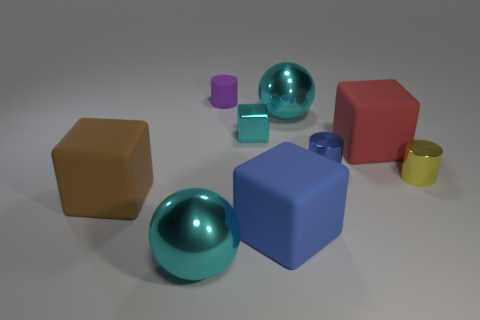Add 1 small yellow metal objects. How many objects exist? 10 Subtract all large rubber blocks. How many blocks are left? 1 Subtract 3 blocks. How many blocks are left? 1 Subtract all balls. How many objects are left? 7 Subtract all blue blocks. How many blocks are left? 3 Subtract all purple cylinders. How many cyan cubes are left? 1 Subtract all big matte objects. Subtract all red matte cubes. How many objects are left? 5 Add 5 tiny purple matte objects. How many tiny purple matte objects are left? 6 Add 2 small shiny cubes. How many small shiny cubes exist? 3 Subtract 0 purple blocks. How many objects are left? 9 